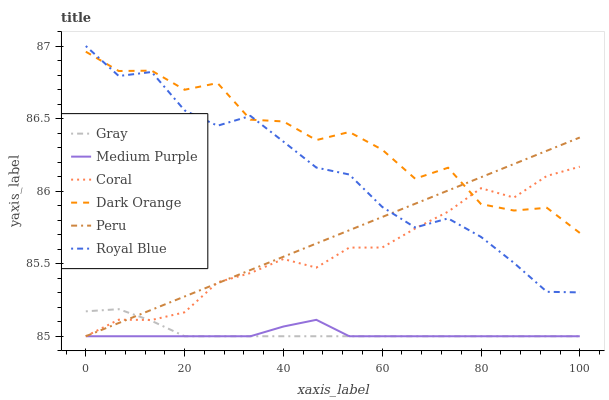Does Coral have the minimum area under the curve?
Answer yes or no. No. Does Coral have the maximum area under the curve?
Answer yes or no. No. Is Coral the smoothest?
Answer yes or no. No. Is Coral the roughest?
Answer yes or no. No. Does Dark Orange have the lowest value?
Answer yes or no. No. Does Dark Orange have the highest value?
Answer yes or no. No. Is Gray less than Royal Blue?
Answer yes or no. Yes. Is Royal Blue greater than Gray?
Answer yes or no. Yes. Does Gray intersect Royal Blue?
Answer yes or no. No. 